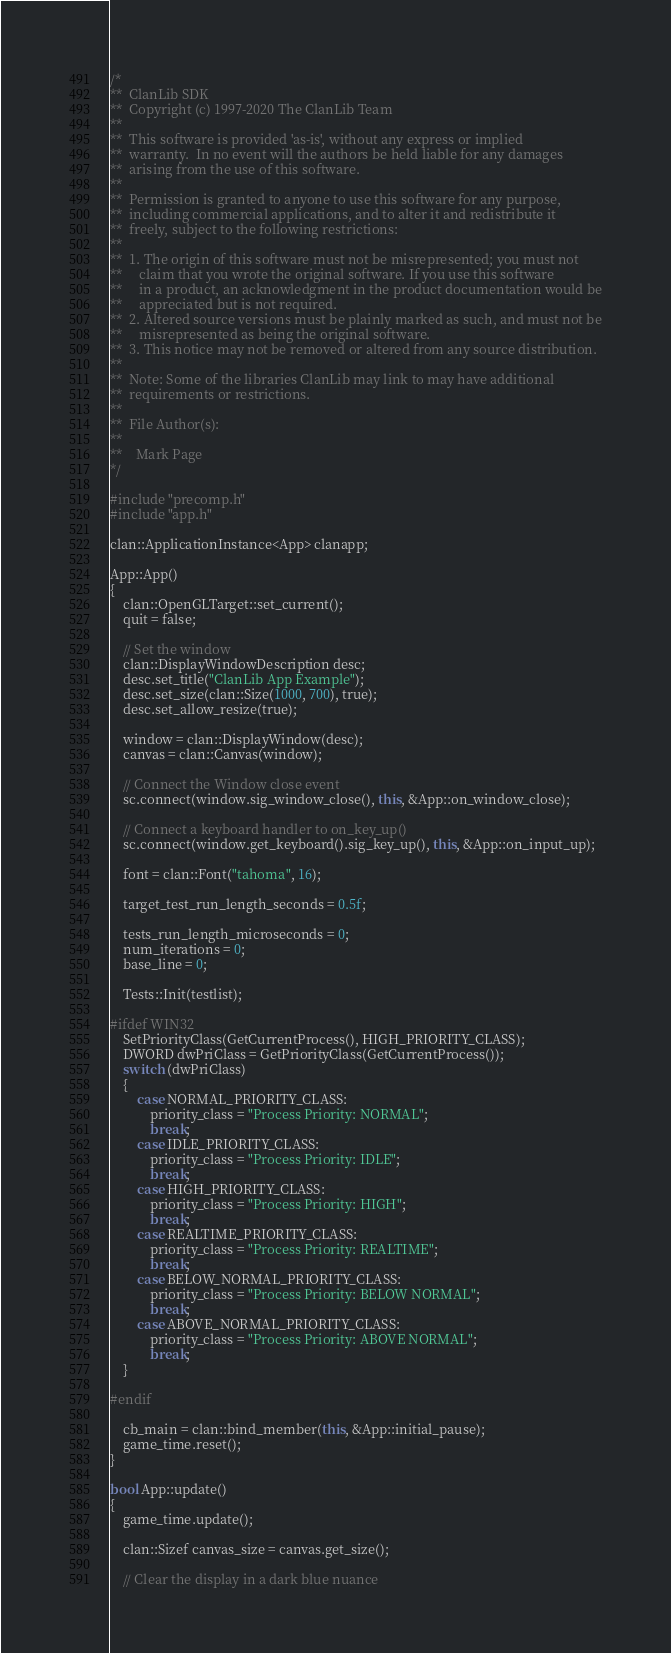Convert code to text. <code><loc_0><loc_0><loc_500><loc_500><_C++_>/*
**  ClanLib SDK
**  Copyright (c) 1997-2020 The ClanLib Team
**
**  This software is provided 'as-is', without any express or implied
**  warranty.  In no event will the authors be held liable for any damages
**  arising from the use of this software.
**
**  Permission is granted to anyone to use this software for any purpose,
**  including commercial applications, and to alter it and redistribute it
**  freely, subject to the following restrictions:
**
**  1. The origin of this software must not be misrepresented; you must not
**     claim that you wrote the original software. If you use this software
**     in a product, an acknowledgment in the product documentation would be
**     appreciated but is not required.
**  2. Altered source versions must be plainly marked as such, and must not be
**     misrepresented as being the original software.
**  3. This notice may not be removed or altered from any source distribution.
**
**  Note: Some of the libraries ClanLib may link to may have additional
**  requirements or restrictions.
**
**  File Author(s):
**
**    Mark Page
*/

#include "precomp.h"
#include "app.h"

clan::ApplicationInstance<App> clanapp;

App::App()
{
	clan::OpenGLTarget::set_current();
	quit = false;

	// Set the window
	clan::DisplayWindowDescription desc;
	desc.set_title("ClanLib App Example");
	desc.set_size(clan::Size(1000, 700), true);
	desc.set_allow_resize(true);

	window = clan::DisplayWindow(desc);
	canvas = clan::Canvas(window);

	// Connect the Window close event
	sc.connect(window.sig_window_close(), this, &App::on_window_close);

	// Connect a keyboard handler to on_key_up()
	sc.connect(window.get_keyboard().sig_key_up(), this, &App::on_input_up);

	font = clan::Font("tahoma", 16);

	target_test_run_length_seconds = 0.5f;

	tests_run_length_microseconds = 0;
	num_iterations = 0;
	base_line = 0;

	Tests::Init(testlist);

#ifdef WIN32
	SetPriorityClass(GetCurrentProcess(), HIGH_PRIORITY_CLASS);
	DWORD dwPriClass = GetPriorityClass(GetCurrentProcess());
	switch (dwPriClass)
	{
		case NORMAL_PRIORITY_CLASS:
			priority_class = "Process Priority: NORMAL";
			break;
		case IDLE_PRIORITY_CLASS:
			priority_class = "Process Priority: IDLE";
			break;
		case HIGH_PRIORITY_CLASS:
			priority_class = "Process Priority: HIGH";
			break;
		case REALTIME_PRIORITY_CLASS:
			priority_class = "Process Priority: REALTIME";
			break;
		case BELOW_NORMAL_PRIORITY_CLASS:
			priority_class = "Process Priority: BELOW NORMAL";
			break;
		case ABOVE_NORMAL_PRIORITY_CLASS:
			priority_class = "Process Priority: ABOVE NORMAL";
			break;
	}
	
#endif

	cb_main = clan::bind_member(this, &App::initial_pause);
	game_time.reset();
}

bool App::update()
{
	game_time.update();

	clan::Sizef canvas_size = canvas.get_size();

	// Clear the display in a dark blue nuance</code> 